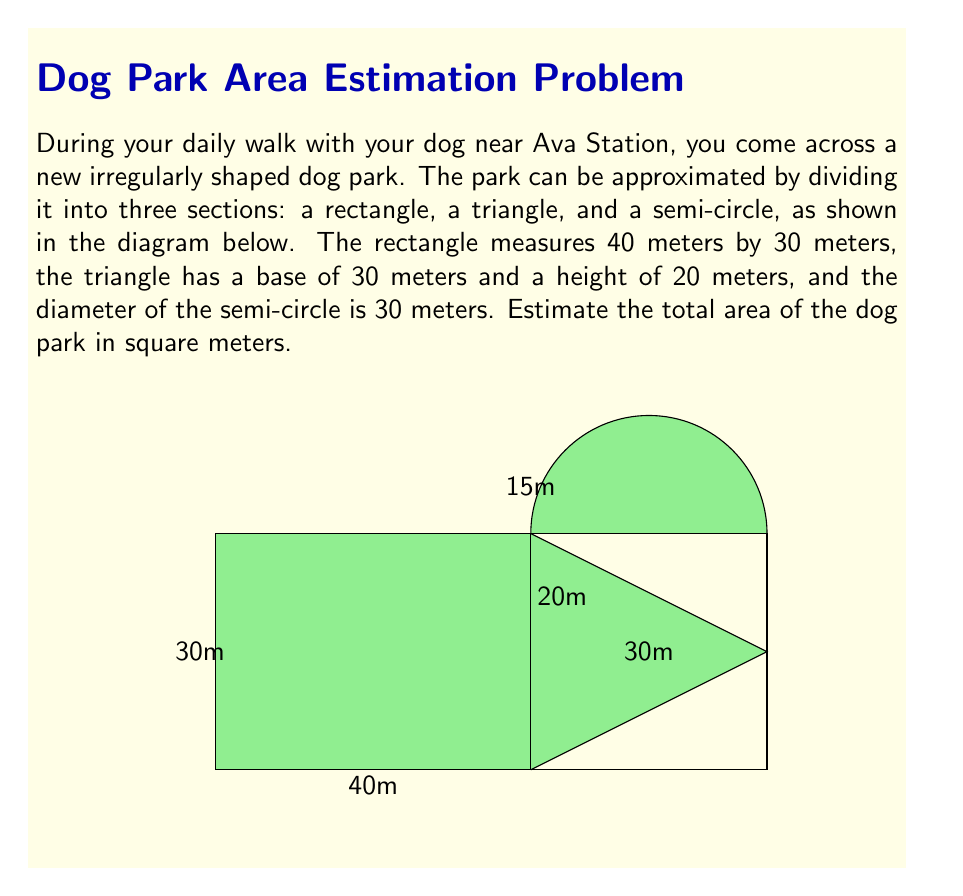Can you answer this question? Let's break this problem down into steps:

1. Calculate the area of the rectangle:
   $$A_{rectangle} = length \times width = 40 \text{ m} \times 30 \text{ m} = 1200 \text{ m}^2$$

2. Calculate the area of the triangle:
   $$A_{triangle} = \frac{1}{2} \times base \times height = \frac{1}{2} \times 30 \text{ m} \times 20 \text{ m} = 300 \text{ m}^2$$

3. Calculate the area of the semi-circle:
   The area of a full circle is $\pi r^2$, where $r$ is the radius. The diameter is 30 m, so the radius is 15 m.
   For a semi-circle, we take half of this area:
   $$A_{semi-circle} = \frac{1}{2} \times \pi r^2 = \frac{1}{2} \times \pi \times (15 \text{ m})^2 \approx 353.43 \text{ m}^2$$

4. Sum up the areas of all three sections:
   $$A_{total} = A_{rectangle} + A_{triangle} + A_{semi-circle}$$
   $$A_{total} = 1200 \text{ m}^2 + 300 \text{ m}^2 + 353.43 \text{ m}^2 = 1853.43 \text{ m}^2$$

5. Round to a reasonable estimate:
   We can round this to 1850 m² or 1900 m² for a reasonable estimate.
Answer: Approximately 1850 m² 